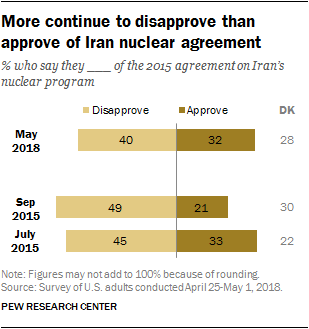Identify some key points in this picture. In September 2015, a survey was conducted to determine the percentage of respondents who approved of the 2015 agreement on Iran's nuclear program. The results showed that 21% of respondents approved of the agreement. The median of the Approve bars is not greater than the smallest Disapprove bar, according to the data provided. 